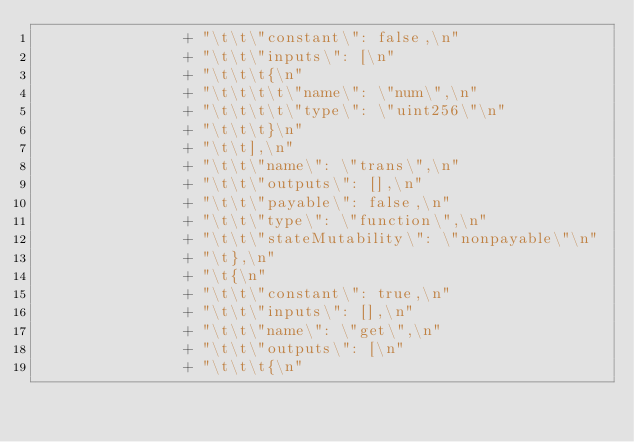Convert code to text. <code><loc_0><loc_0><loc_500><loc_500><_Java_>                + "\t\t\"constant\": false,\n"
                + "\t\t\"inputs\": [\n"
                + "\t\t\t{\n"
                + "\t\t\t\t\"name\": \"num\",\n"
                + "\t\t\t\t\"type\": \"uint256\"\n"
                + "\t\t\t}\n"
                + "\t\t],\n"
                + "\t\t\"name\": \"trans\",\n"
                + "\t\t\"outputs\": [],\n"
                + "\t\t\"payable\": false,\n"
                + "\t\t\"type\": \"function\",\n"
                + "\t\t\"stateMutability\": \"nonpayable\"\n"
                + "\t},\n"
                + "\t{\n"
                + "\t\t\"constant\": true,\n"
                + "\t\t\"inputs\": [],\n"
                + "\t\t\"name\": \"get\",\n"
                + "\t\t\"outputs\": [\n"
                + "\t\t\t{\n"</code> 